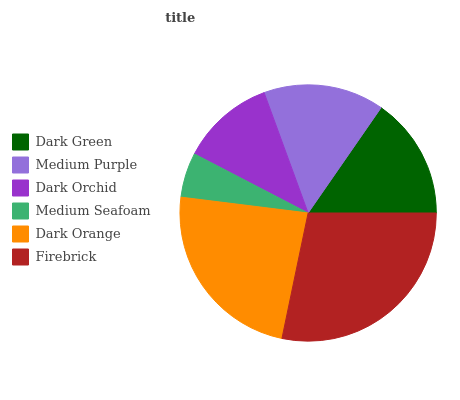Is Medium Seafoam the minimum?
Answer yes or no. Yes. Is Firebrick the maximum?
Answer yes or no. Yes. Is Medium Purple the minimum?
Answer yes or no. No. Is Medium Purple the maximum?
Answer yes or no. No. Is Dark Green greater than Medium Purple?
Answer yes or no. Yes. Is Medium Purple less than Dark Green?
Answer yes or no. Yes. Is Medium Purple greater than Dark Green?
Answer yes or no. No. Is Dark Green less than Medium Purple?
Answer yes or no. No. Is Dark Green the high median?
Answer yes or no. Yes. Is Medium Purple the low median?
Answer yes or no. Yes. Is Dark Orchid the high median?
Answer yes or no. No. Is Dark Orchid the low median?
Answer yes or no. No. 